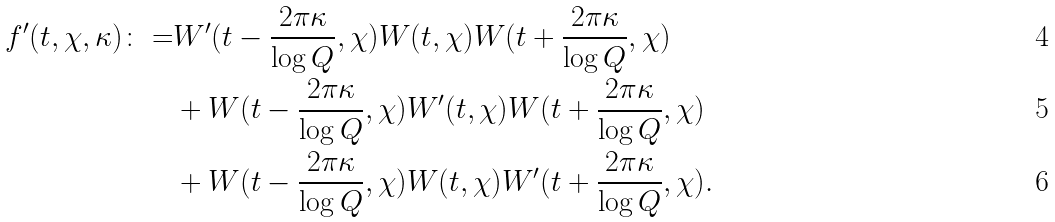Convert formula to latex. <formula><loc_0><loc_0><loc_500><loc_500>f ^ { \prime } ( t , \chi , \kappa ) \colon = & W ^ { \prime } ( t - \frac { 2 \pi \kappa } { \log Q } , \chi ) W ( t , \chi ) W ( t + \frac { 2 \pi \kappa } { \log Q } , \chi ) \\ & + W ( t - \frac { 2 \pi \kappa } { \log Q } , \chi ) W ^ { \prime } ( t , \chi ) W ( t + \frac { 2 \pi \kappa } { \log Q } , \chi ) \\ & + W ( t - \frac { 2 \pi \kappa } { \log Q } , \chi ) W ( t , \chi ) W ^ { \prime } ( t + \frac { 2 \pi \kappa } { \log Q } , \chi ) .</formula> 